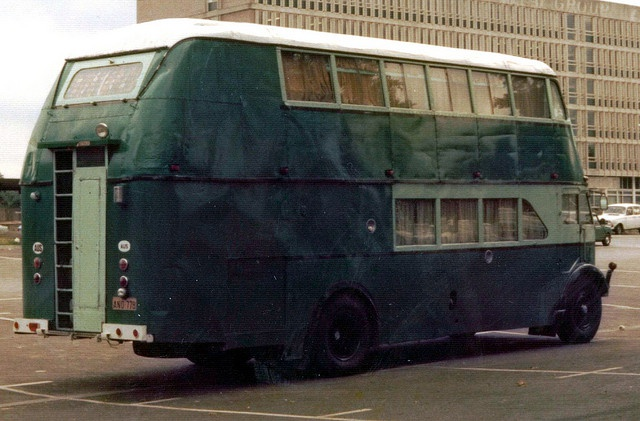Describe the objects in this image and their specific colors. I can see bus in black, white, and gray tones, car in white, darkgray, gray, and lightgray tones, and car in white, gray, darkgreen, black, and darkgray tones in this image. 